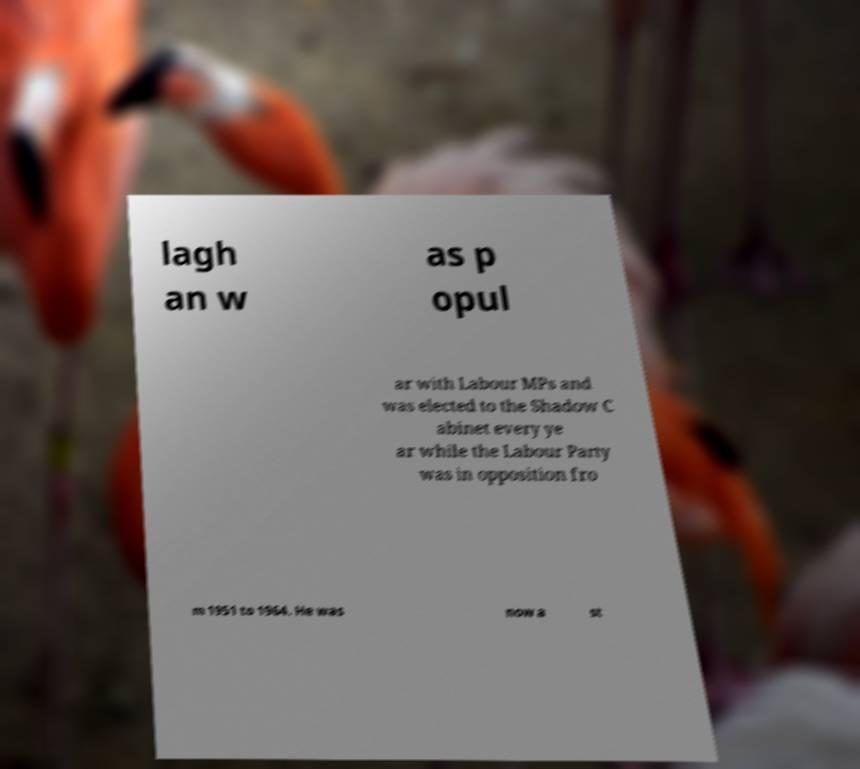What messages or text are displayed in this image? I need them in a readable, typed format. lagh an w as p opul ar with Labour MPs and was elected to the Shadow C abinet every ye ar while the Labour Party was in opposition fro m 1951 to 1964. He was now a st 